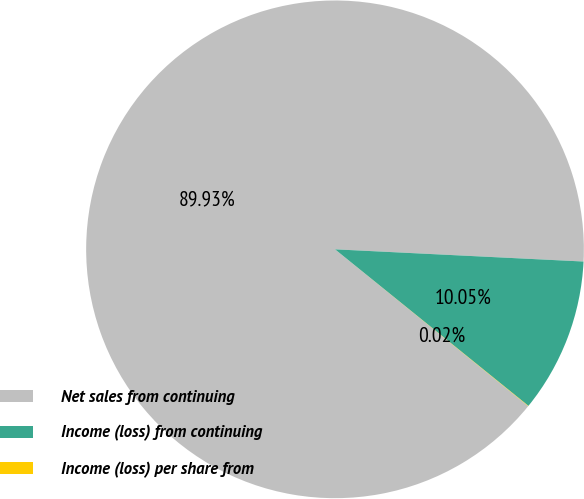Convert chart to OTSL. <chart><loc_0><loc_0><loc_500><loc_500><pie_chart><fcel>Net sales from continuing<fcel>Income (loss) from continuing<fcel>Income (loss) per share from<nl><fcel>89.93%<fcel>10.05%<fcel>0.02%<nl></chart> 